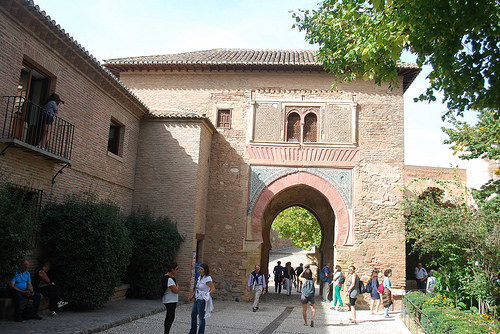<image>
Can you confirm if the leaves is in front of the building? Yes. The leaves is positioned in front of the building, appearing closer to the camera viewpoint. 